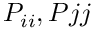Convert formula to latex. <formula><loc_0><loc_0><loc_500><loc_500>P _ { i i } , P { j j }</formula> 